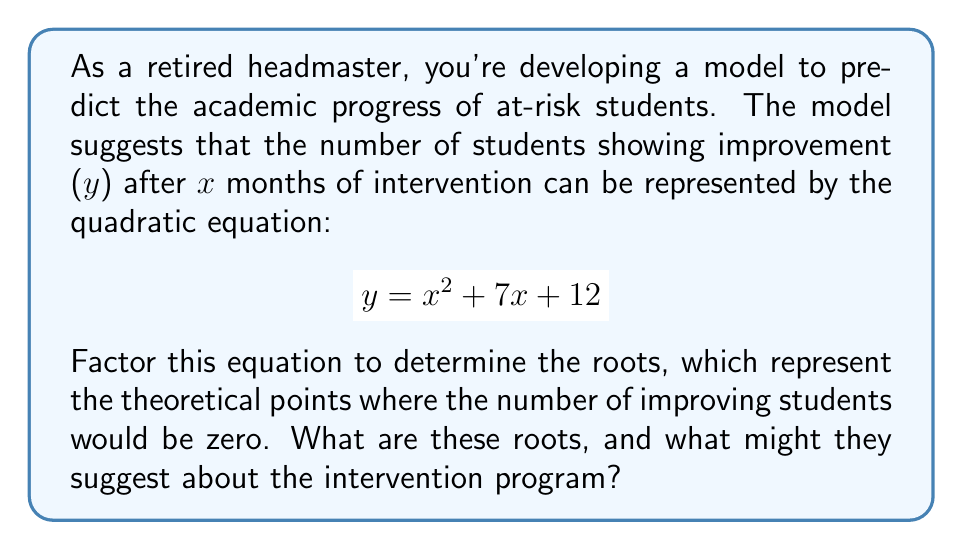Can you solve this math problem? Let's approach this step-by-step:

1) We start with the quadratic equation: $y = x^2 + 7x + 12$

2) To factor this, we need to find two numbers that multiply to give 12 (the constant term) and add up to 7 (the coefficient of x).

3) These numbers are 3 and 4, as $3 \times 4 = 12$ and $3 + 4 = 7$

4) We can rewrite the equation as:
   $y = x^2 + 3x + 4x + 12$

5) Grouping these terms:
   $y = (x^2 + 3x) + (4x + 12)$

6) Factoring out the common factors:
   $y = x(x + 3) + 4(x + 3)$

7) We can now factor out $(x + 3)$:
   $y = (x + 3)(x + 4)$

8) Setting $y = 0$, we get:
   $0 = (x + 3)(x + 4)$

9) This is true when either $(x + 3) = 0$ or $(x + 4) = 0$

10) Solving these:
    $x + 3 = 0$ gives $x = -3$
    $x + 4 = 0$ gives $x = -4$

Therefore, the roots are -3 and -4.

In the context of the intervention program, these roots suggest that theoretically, the number of students showing improvement would be zero at -3 and -4 months before the start of the intervention. This doesn't have a practical interpretation in terms of time, but it does indicate that the program starts showing positive effects immediately (since both roots are negative).
Answer: $x = -3$ and $x = -4$ 